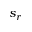<formula> <loc_0><loc_0><loc_500><loc_500>s _ { r }</formula> 